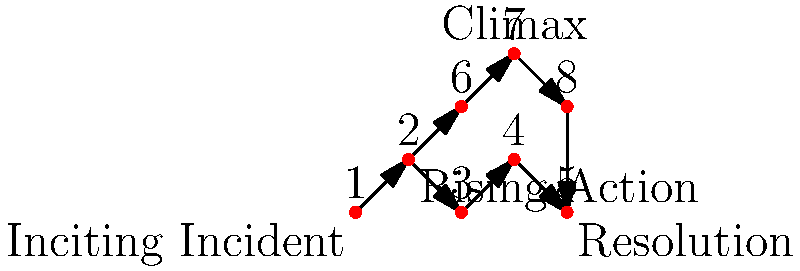In the directed acyclic graph representing a story's plot structure, how many distinct paths exist from the Inciting Incident (vertex 1) to the Resolution (vertex 5)? To determine the number of distinct paths from the Inciting Incident to the Resolution, we need to follow these steps:

1. Identify the starting point (Inciting Incident, vertex 1) and ending point (Resolution, vertex 5).

2. Trace all possible paths between these points:
   Path 1: 1 → 2 → 3 → 4 → 5
   Path 2: 1 → 2 → 6 → 7 → 8 → 5

3. Count the number of distinct paths:
   There are 2 distinct paths from vertex 1 to vertex 5.

This graph structure demonstrates a common storytelling technique in epic fantasy, where the main plot (Path 1) is complemented by a significant subplot or parallel storyline (Path 2). Both paths contribute to the overall narrative and converge at the resolution, creating a rich and complex story structure.
Answer: 2 distinct paths 